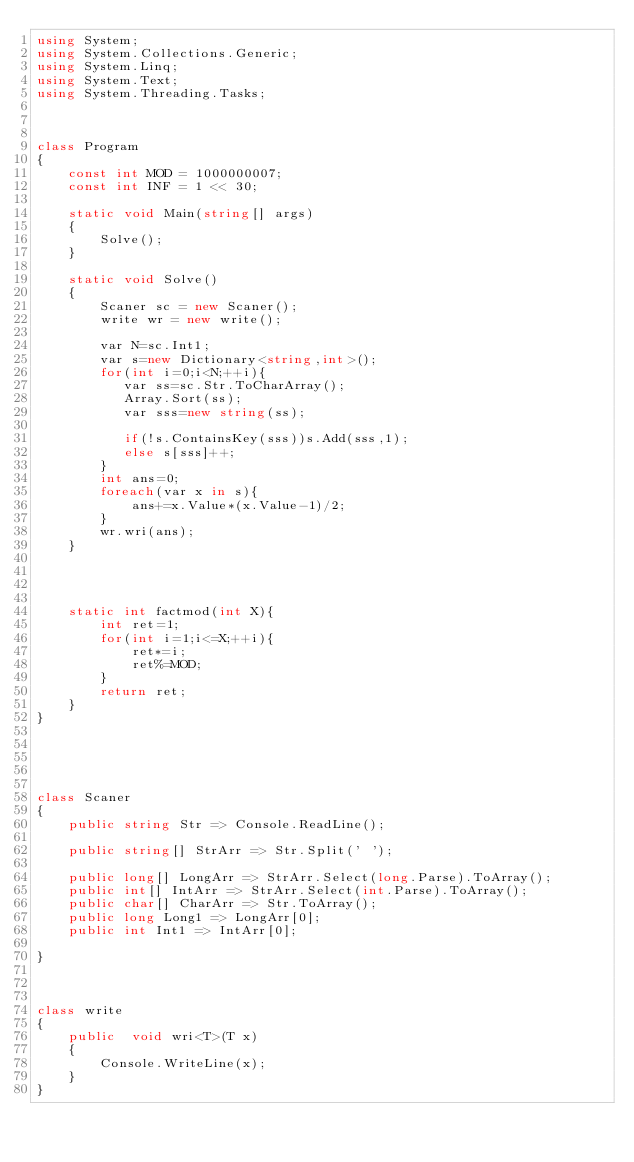<code> <loc_0><loc_0><loc_500><loc_500><_C#_>using System;
using System.Collections.Generic;
using System.Linq;
using System.Text;
using System.Threading.Tasks;



class Program
{
    const int MOD = 1000000007;
    const int INF = 1 << 30;

    static void Main(string[] args)
    {
        Solve();
    }

    static void Solve()
    {
        Scaner sc = new Scaner();
        write wr = new write();

        var N=sc.Int1;
        var s=new Dictionary<string,int>();
        for(int i=0;i<N;++i){
           var ss=sc.Str.ToCharArray();
           Array.Sort(ss);
           var sss=new string(ss);

           if(!s.ContainsKey(sss))s.Add(sss,1);
           else s[sss]++;
        }
        int ans=0;
        foreach(var x in s){
            ans+=x.Value*(x.Value-1)/2;
        }
        wr.wri(ans);
    }
    
        


    static int factmod(int X){
        int ret=1;
        for(int i=1;i<=X;++i){
            ret*=i;
            ret%=MOD;
        }
        return ret;
    }
}





class Scaner
{
    public string Str => Console.ReadLine();

    public string[] StrArr => Str.Split(' ');

    public long[] LongArr => StrArr.Select(long.Parse).ToArray();
    public int[] IntArr => StrArr.Select(int.Parse).ToArray();
    public char[] CharArr => Str.ToArray();
    public long Long1 => LongArr[0];
    public int Int1 => IntArr[0];
    
}



class write
{
    public  void wri<T>(T x)
    {
        Console.WriteLine(x);
    }
}

</code> 